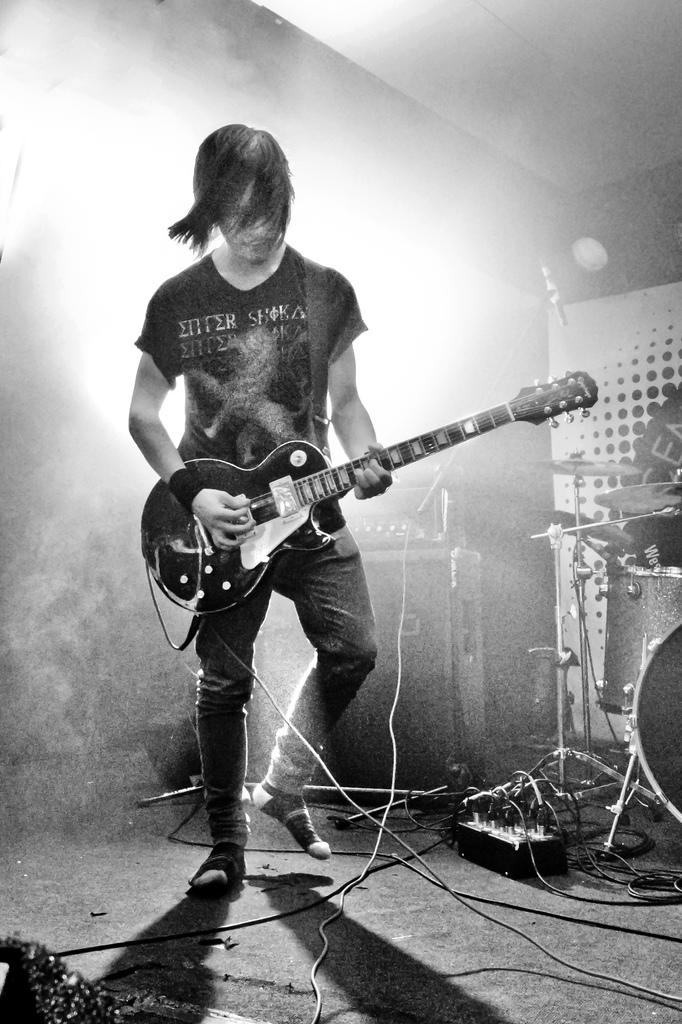Who is the main subject in the image? There is a man in the image. What is the man doing in the image? The man is playing a guitar. Where is the man located in the image? The man is on a stage. What else can be seen on the stage in the image? There are musical instruments on the stage. Can you see a bottle floating in the lake in the image? There is no bottle or lake present in the image; it features a man playing a guitar on a stage with musical instruments. 